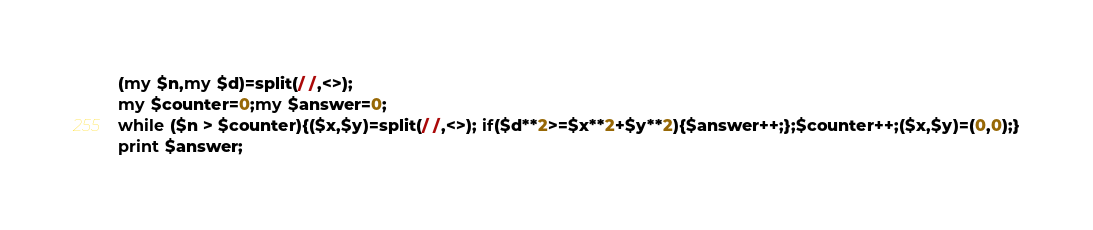Convert code to text. <code><loc_0><loc_0><loc_500><loc_500><_Perl_>(my $n,my $d)=split(/ /,<>);
my $counter=0;my $answer=0;
while ($n > $counter){($x,$y)=split(/ /,<>); if($d**2>=$x**2+$y**2){$answer++;};$counter++;($x,$y)=(0,0);}
print $answer;</code> 